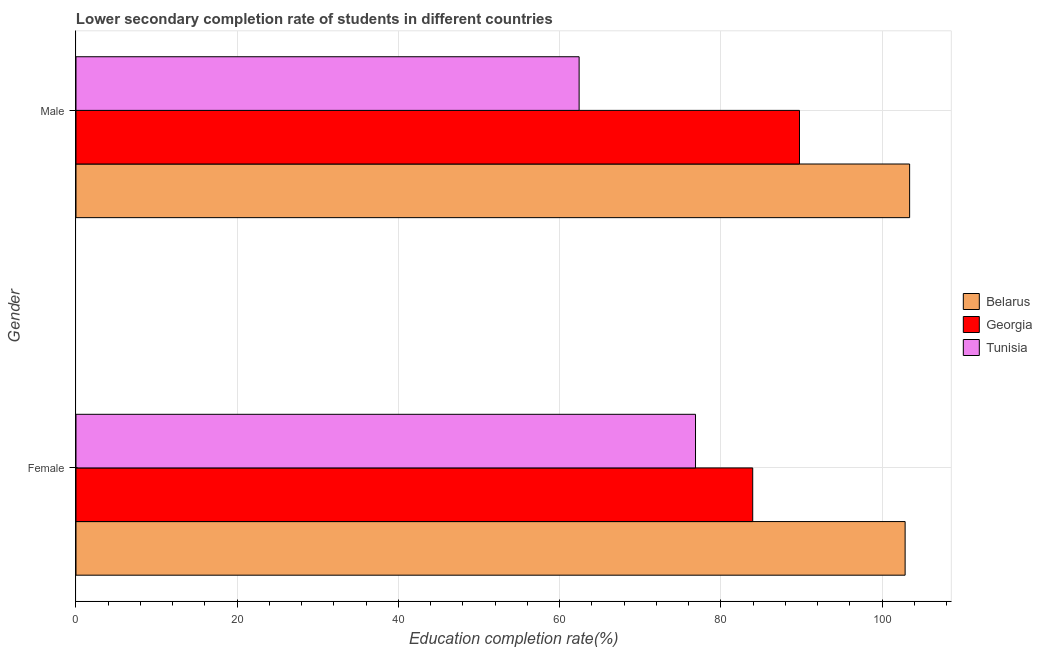How many different coloured bars are there?
Provide a short and direct response. 3. How many groups of bars are there?
Your response must be concise. 2. Are the number of bars on each tick of the Y-axis equal?
Make the answer very short. Yes. How many bars are there on the 2nd tick from the bottom?
Offer a very short reply. 3. What is the label of the 1st group of bars from the top?
Your answer should be very brief. Male. What is the education completion rate of male students in Georgia?
Your response must be concise. 89.75. Across all countries, what is the maximum education completion rate of male students?
Give a very brief answer. 103.41. Across all countries, what is the minimum education completion rate of male students?
Provide a succinct answer. 62.41. In which country was the education completion rate of male students maximum?
Your answer should be very brief. Belarus. In which country was the education completion rate of female students minimum?
Offer a terse response. Tunisia. What is the total education completion rate of female students in the graph?
Keep it short and to the point. 263.65. What is the difference between the education completion rate of male students in Belarus and that in Georgia?
Offer a very short reply. 13.66. What is the difference between the education completion rate of male students in Tunisia and the education completion rate of female students in Belarus?
Provide a short and direct response. -40.44. What is the average education completion rate of female students per country?
Your answer should be compact. 87.88. What is the difference between the education completion rate of male students and education completion rate of female students in Belarus?
Ensure brevity in your answer.  0.56. What is the ratio of the education completion rate of female students in Georgia to that in Tunisia?
Make the answer very short. 1.09. In how many countries, is the education completion rate of male students greater than the average education completion rate of male students taken over all countries?
Keep it short and to the point. 2. What does the 1st bar from the top in Male represents?
Ensure brevity in your answer.  Tunisia. What does the 3rd bar from the bottom in Male represents?
Provide a succinct answer. Tunisia. How many bars are there?
Offer a terse response. 6. Are all the bars in the graph horizontal?
Give a very brief answer. Yes. How many countries are there in the graph?
Keep it short and to the point. 3. Does the graph contain grids?
Provide a succinct answer. Yes. What is the title of the graph?
Provide a short and direct response. Lower secondary completion rate of students in different countries. What is the label or title of the X-axis?
Give a very brief answer. Education completion rate(%). What is the Education completion rate(%) of Belarus in Female?
Give a very brief answer. 102.85. What is the Education completion rate(%) in Georgia in Female?
Provide a short and direct response. 83.95. What is the Education completion rate(%) in Tunisia in Female?
Your response must be concise. 76.85. What is the Education completion rate(%) in Belarus in Male?
Your answer should be very brief. 103.41. What is the Education completion rate(%) in Georgia in Male?
Provide a succinct answer. 89.75. What is the Education completion rate(%) in Tunisia in Male?
Your response must be concise. 62.41. Across all Gender, what is the maximum Education completion rate(%) of Belarus?
Your answer should be compact. 103.41. Across all Gender, what is the maximum Education completion rate(%) in Georgia?
Offer a very short reply. 89.75. Across all Gender, what is the maximum Education completion rate(%) in Tunisia?
Make the answer very short. 76.85. Across all Gender, what is the minimum Education completion rate(%) of Belarus?
Offer a very short reply. 102.85. Across all Gender, what is the minimum Education completion rate(%) in Georgia?
Provide a short and direct response. 83.95. Across all Gender, what is the minimum Education completion rate(%) in Tunisia?
Make the answer very short. 62.41. What is the total Education completion rate(%) in Belarus in the graph?
Your response must be concise. 206.27. What is the total Education completion rate(%) in Georgia in the graph?
Your answer should be very brief. 173.7. What is the total Education completion rate(%) of Tunisia in the graph?
Offer a very short reply. 139.27. What is the difference between the Education completion rate(%) in Belarus in Female and that in Male?
Provide a short and direct response. -0.56. What is the difference between the Education completion rate(%) in Georgia in Female and that in Male?
Give a very brief answer. -5.8. What is the difference between the Education completion rate(%) of Tunisia in Female and that in Male?
Your answer should be compact. 14.44. What is the difference between the Education completion rate(%) in Belarus in Female and the Education completion rate(%) in Georgia in Male?
Offer a very short reply. 13.1. What is the difference between the Education completion rate(%) in Belarus in Female and the Education completion rate(%) in Tunisia in Male?
Offer a very short reply. 40.44. What is the difference between the Education completion rate(%) of Georgia in Female and the Education completion rate(%) of Tunisia in Male?
Your response must be concise. 21.53. What is the average Education completion rate(%) in Belarus per Gender?
Your answer should be very brief. 103.13. What is the average Education completion rate(%) of Georgia per Gender?
Your response must be concise. 86.85. What is the average Education completion rate(%) in Tunisia per Gender?
Ensure brevity in your answer.  69.63. What is the difference between the Education completion rate(%) in Belarus and Education completion rate(%) in Georgia in Female?
Keep it short and to the point. 18.91. What is the difference between the Education completion rate(%) in Belarus and Education completion rate(%) in Tunisia in Female?
Offer a terse response. 26. What is the difference between the Education completion rate(%) of Georgia and Education completion rate(%) of Tunisia in Female?
Your response must be concise. 7.1. What is the difference between the Education completion rate(%) in Belarus and Education completion rate(%) in Georgia in Male?
Ensure brevity in your answer.  13.66. What is the difference between the Education completion rate(%) of Belarus and Education completion rate(%) of Tunisia in Male?
Your answer should be very brief. 41. What is the difference between the Education completion rate(%) in Georgia and Education completion rate(%) in Tunisia in Male?
Provide a short and direct response. 27.34. What is the ratio of the Education completion rate(%) of Belarus in Female to that in Male?
Make the answer very short. 0.99. What is the ratio of the Education completion rate(%) of Georgia in Female to that in Male?
Your answer should be compact. 0.94. What is the ratio of the Education completion rate(%) of Tunisia in Female to that in Male?
Your answer should be compact. 1.23. What is the difference between the highest and the second highest Education completion rate(%) in Belarus?
Your answer should be compact. 0.56. What is the difference between the highest and the second highest Education completion rate(%) in Georgia?
Make the answer very short. 5.8. What is the difference between the highest and the second highest Education completion rate(%) of Tunisia?
Give a very brief answer. 14.44. What is the difference between the highest and the lowest Education completion rate(%) in Belarus?
Your answer should be very brief. 0.56. What is the difference between the highest and the lowest Education completion rate(%) in Georgia?
Offer a terse response. 5.8. What is the difference between the highest and the lowest Education completion rate(%) in Tunisia?
Make the answer very short. 14.44. 